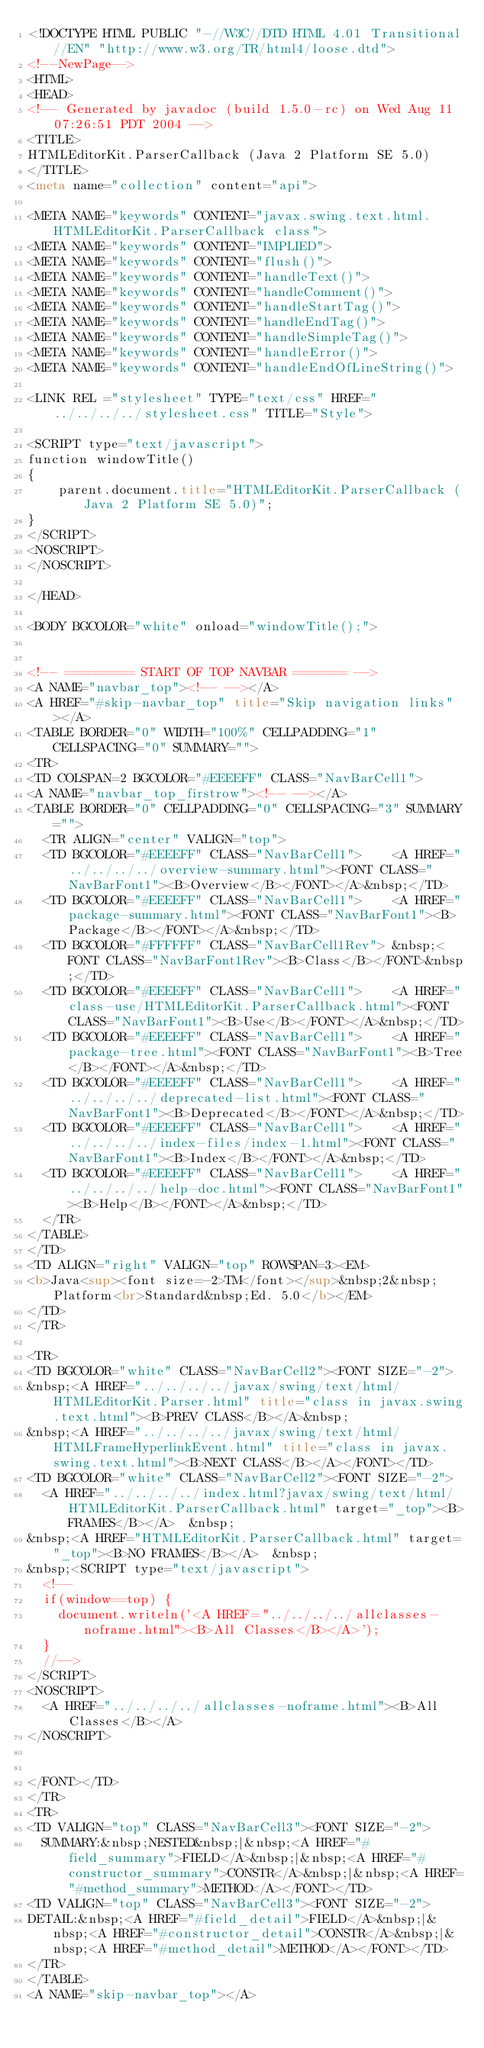Convert code to text. <code><loc_0><loc_0><loc_500><loc_500><_HTML_><!DOCTYPE HTML PUBLIC "-//W3C//DTD HTML 4.01 Transitional//EN" "http://www.w3.org/TR/html4/loose.dtd">
<!--NewPage-->
<HTML>
<HEAD>
<!-- Generated by javadoc (build 1.5.0-rc) on Wed Aug 11 07:26:51 PDT 2004 -->
<TITLE>
HTMLEditorKit.ParserCallback (Java 2 Platform SE 5.0)
</TITLE>
<meta name="collection" content="api">

<META NAME="keywords" CONTENT="javax.swing.text.html.HTMLEditorKit.ParserCallback class">
<META NAME="keywords" CONTENT="IMPLIED">
<META NAME="keywords" CONTENT="flush()">
<META NAME="keywords" CONTENT="handleText()">
<META NAME="keywords" CONTENT="handleComment()">
<META NAME="keywords" CONTENT="handleStartTag()">
<META NAME="keywords" CONTENT="handleEndTag()">
<META NAME="keywords" CONTENT="handleSimpleTag()">
<META NAME="keywords" CONTENT="handleError()">
<META NAME="keywords" CONTENT="handleEndOfLineString()">

<LINK REL ="stylesheet" TYPE="text/css" HREF="../../../../stylesheet.css" TITLE="Style">

<SCRIPT type="text/javascript">
function windowTitle()
{
    parent.document.title="HTMLEditorKit.ParserCallback (Java 2 Platform SE 5.0)";
}
</SCRIPT>
<NOSCRIPT>
</NOSCRIPT>

</HEAD>

<BODY BGCOLOR="white" onload="windowTitle();">


<!-- ========= START OF TOP NAVBAR ======= -->
<A NAME="navbar_top"><!-- --></A>
<A HREF="#skip-navbar_top" title="Skip navigation links"></A>
<TABLE BORDER="0" WIDTH="100%" CELLPADDING="1" CELLSPACING="0" SUMMARY="">
<TR>
<TD COLSPAN=2 BGCOLOR="#EEEEFF" CLASS="NavBarCell1">
<A NAME="navbar_top_firstrow"><!-- --></A>
<TABLE BORDER="0" CELLPADDING="0" CELLSPACING="3" SUMMARY="">
  <TR ALIGN="center" VALIGN="top">
  <TD BGCOLOR="#EEEEFF" CLASS="NavBarCell1">    <A HREF="../../../../overview-summary.html"><FONT CLASS="NavBarFont1"><B>Overview</B></FONT></A>&nbsp;</TD>
  <TD BGCOLOR="#EEEEFF" CLASS="NavBarCell1">    <A HREF="package-summary.html"><FONT CLASS="NavBarFont1"><B>Package</B></FONT></A>&nbsp;</TD>
  <TD BGCOLOR="#FFFFFF" CLASS="NavBarCell1Rev"> &nbsp;<FONT CLASS="NavBarFont1Rev"><B>Class</B></FONT>&nbsp;</TD>
  <TD BGCOLOR="#EEEEFF" CLASS="NavBarCell1">    <A HREF="class-use/HTMLEditorKit.ParserCallback.html"><FONT CLASS="NavBarFont1"><B>Use</B></FONT></A>&nbsp;</TD>
  <TD BGCOLOR="#EEEEFF" CLASS="NavBarCell1">    <A HREF="package-tree.html"><FONT CLASS="NavBarFont1"><B>Tree</B></FONT></A>&nbsp;</TD>
  <TD BGCOLOR="#EEEEFF" CLASS="NavBarCell1">    <A HREF="../../../../deprecated-list.html"><FONT CLASS="NavBarFont1"><B>Deprecated</B></FONT></A>&nbsp;</TD>
  <TD BGCOLOR="#EEEEFF" CLASS="NavBarCell1">    <A HREF="../../../../index-files/index-1.html"><FONT CLASS="NavBarFont1"><B>Index</B></FONT></A>&nbsp;</TD>
  <TD BGCOLOR="#EEEEFF" CLASS="NavBarCell1">    <A HREF="../../../../help-doc.html"><FONT CLASS="NavBarFont1"><B>Help</B></FONT></A>&nbsp;</TD>
  </TR>
</TABLE>
</TD>
<TD ALIGN="right" VALIGN="top" ROWSPAN=3><EM>
<b>Java<sup><font size=-2>TM</font></sup>&nbsp;2&nbsp;Platform<br>Standard&nbsp;Ed. 5.0</b></EM>
</TD>
</TR>

<TR>
<TD BGCOLOR="white" CLASS="NavBarCell2"><FONT SIZE="-2">
&nbsp;<A HREF="../../../../javax/swing/text/html/HTMLEditorKit.Parser.html" title="class in javax.swing.text.html"><B>PREV CLASS</B></A>&nbsp;
&nbsp;<A HREF="../../../../javax/swing/text/html/HTMLFrameHyperlinkEvent.html" title="class in javax.swing.text.html"><B>NEXT CLASS</B></A></FONT></TD>
<TD BGCOLOR="white" CLASS="NavBarCell2"><FONT SIZE="-2">
  <A HREF="../../../../index.html?javax/swing/text/html/HTMLEditorKit.ParserCallback.html" target="_top"><B>FRAMES</B></A>  &nbsp;
&nbsp;<A HREF="HTMLEditorKit.ParserCallback.html" target="_top"><B>NO FRAMES</B></A>  &nbsp;
&nbsp;<SCRIPT type="text/javascript">
  <!--
  if(window==top) {
    document.writeln('<A HREF="../../../../allclasses-noframe.html"><B>All Classes</B></A>');
  }
  //-->
</SCRIPT>
<NOSCRIPT>
  <A HREF="../../../../allclasses-noframe.html"><B>All Classes</B></A>
</NOSCRIPT>


</FONT></TD>
</TR>
<TR>
<TD VALIGN="top" CLASS="NavBarCell3"><FONT SIZE="-2">
  SUMMARY:&nbsp;NESTED&nbsp;|&nbsp;<A HREF="#field_summary">FIELD</A>&nbsp;|&nbsp;<A HREF="#constructor_summary">CONSTR</A>&nbsp;|&nbsp;<A HREF="#method_summary">METHOD</A></FONT></TD>
<TD VALIGN="top" CLASS="NavBarCell3"><FONT SIZE="-2">
DETAIL:&nbsp;<A HREF="#field_detail">FIELD</A>&nbsp;|&nbsp;<A HREF="#constructor_detail">CONSTR</A>&nbsp;|&nbsp;<A HREF="#method_detail">METHOD</A></FONT></TD>
</TR>
</TABLE>
<A NAME="skip-navbar_top"></A></code> 